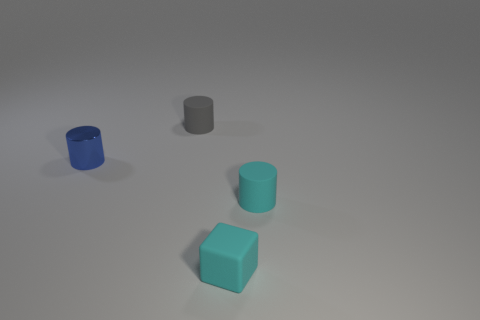Add 4 gray matte things. How many objects exist? 8 Subtract all cylinders. How many objects are left? 1 Subtract 0 green blocks. How many objects are left? 4 Subtract all small cyan cubes. Subtract all small gray objects. How many objects are left? 2 Add 2 gray cylinders. How many gray cylinders are left? 3 Add 1 gray rubber cylinders. How many gray rubber cylinders exist? 2 